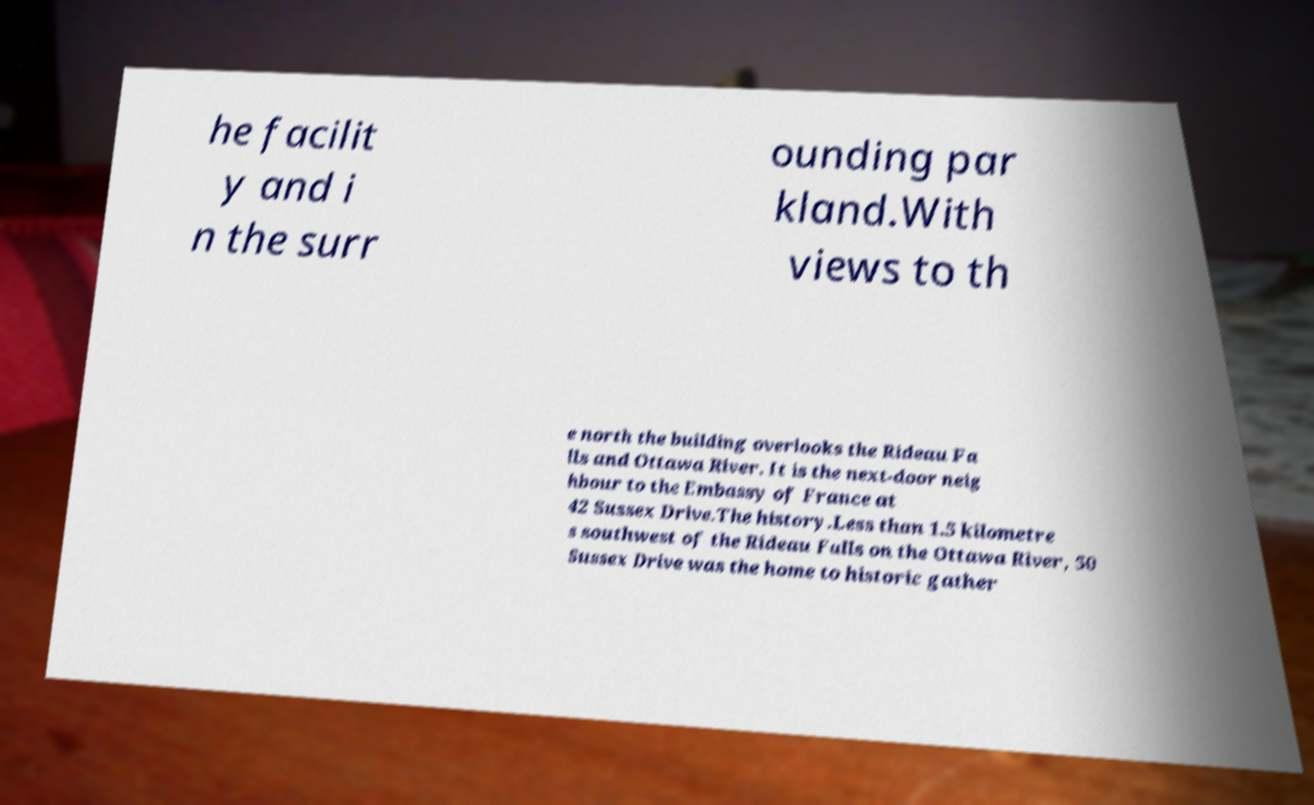Could you assist in decoding the text presented in this image and type it out clearly? he facilit y and i n the surr ounding par kland.With views to th e north the building overlooks the Rideau Fa lls and Ottawa River. It is the next-door neig hbour to the Embassy of France at 42 Sussex Drive.The history.Less than 1.5 kilometre s southwest of the Rideau Falls on the Ottawa River, 50 Sussex Drive was the home to historic gather 